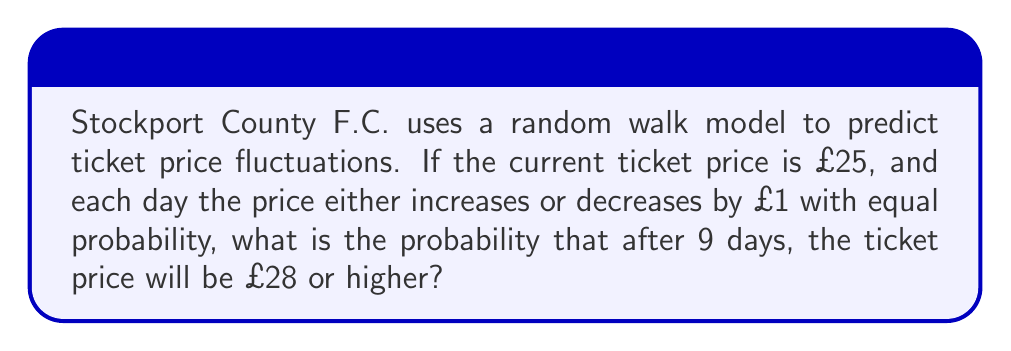Show me your answer to this math problem. Let's approach this step-by-step:

1) This scenario describes a simple symmetric random walk. The price changes can be modeled as independent Bernoulli trials, where:
   - Success (price increase): $p = 0.5$
   - Failure (price decrease): $q = 1 - p = 0.5$

2) To reach £28 or higher from £25, we need at least 3 more increases than decreases.

3) Let $X$ be the number of increases after 9 days. We need to find $P(X - (9-X) \geq 3)$, which simplifies to $P(X \geq 6)$.

4) $X$ follows a Binomial distribution with $n = 9$ and $p = 0.5$. We can use the binomial probability formula:

   $$P(X = k) = \binom{n}{k} p^k (1-p)^{n-k}$$

5) We need to sum the probabilities for $X = 6$, $X = 7$, $X = 8$, and $X = 9$:

   $$P(X \geq 6) = P(X = 6) + P(X = 7) + P(X = 8) + P(X = 9)$$

6) Calculating each term:
   
   $$P(X = 6) = \binom{9}{6} (0.5)^6 (0.5)^3 = 84 * (1/64) * (1/8) = 84/512$$
   $$P(X = 7) = \binom{9}{7} (0.5)^7 (0.5)^2 = 36 * (1/128) * (1/4) = 36/512$$
   $$P(X = 8) = \binom{9}{8} (0.5)^8 (0.5)^1 = 9 * (1/256) * (1/2) = 9/512$$
   $$P(X = 9) = \binom{9}{9} (0.5)^9 (0.5)^0 = 1 * (1/512) * 1 = 1/512$$

7) Summing these probabilities:

   $$P(X \geq 6) = (84 + 36 + 9 + 1) / 512 = 130 / 512 = 65 / 256 \approx 0.254$$

Therefore, the probability that the ticket price will be £28 or higher after 9 days is approximately 0.254 or 25.4%.
Answer: $\frac{65}{256} \approx 0.254$ or $25.4\%$ 